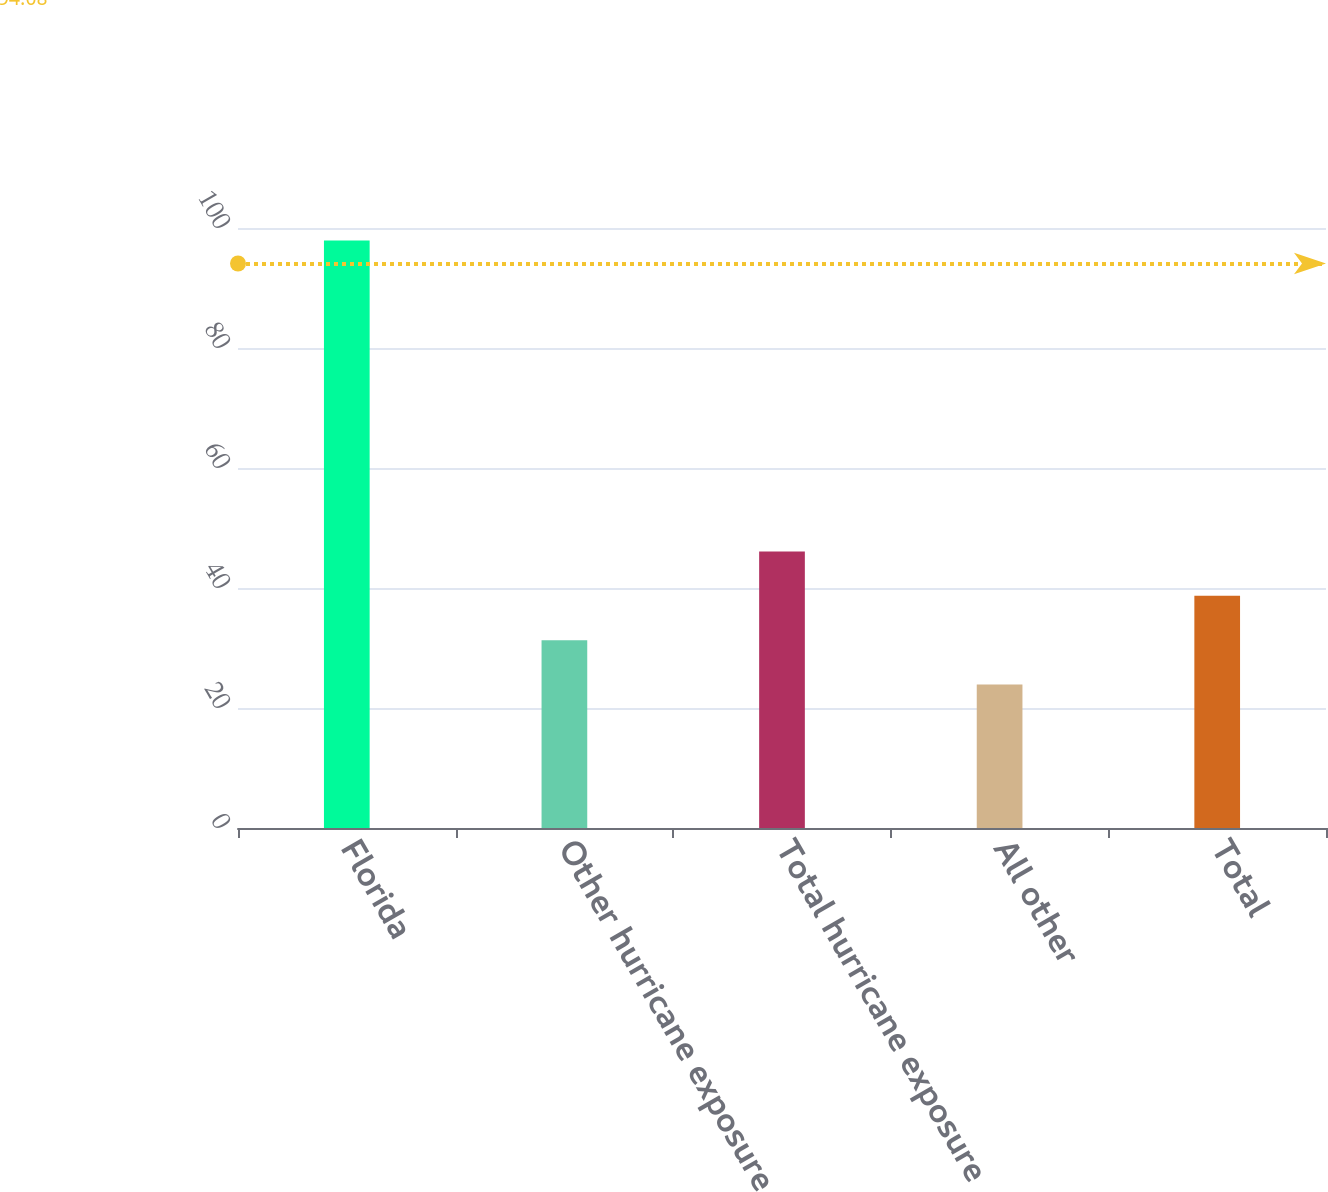Convert chart. <chart><loc_0><loc_0><loc_500><loc_500><bar_chart><fcel>Florida<fcel>Other hurricane exposure<fcel>Total hurricane exposure<fcel>All other<fcel>Total<nl><fcel>97.9<fcel>31.3<fcel>46.1<fcel>23.9<fcel>38.7<nl></chart> 